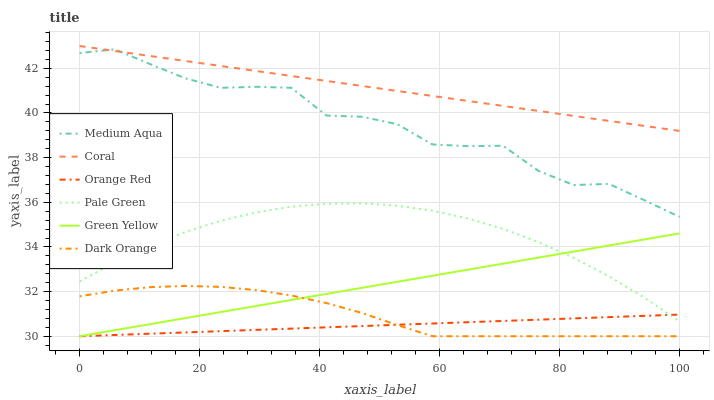Does Orange Red have the minimum area under the curve?
Answer yes or no. Yes. Does Coral have the maximum area under the curve?
Answer yes or no. Yes. Does Pale Green have the minimum area under the curve?
Answer yes or no. No. Does Pale Green have the maximum area under the curve?
Answer yes or no. No. Is Green Yellow the smoothest?
Answer yes or no. Yes. Is Medium Aqua the roughest?
Answer yes or no. Yes. Is Coral the smoothest?
Answer yes or no. No. Is Coral the roughest?
Answer yes or no. No. Does Dark Orange have the lowest value?
Answer yes or no. Yes. Does Pale Green have the lowest value?
Answer yes or no. No. Does Coral have the highest value?
Answer yes or no. Yes. Does Pale Green have the highest value?
Answer yes or no. No. Is Green Yellow less than Medium Aqua?
Answer yes or no. Yes. Is Coral greater than Orange Red?
Answer yes or no. Yes. Does Dark Orange intersect Orange Red?
Answer yes or no. Yes. Is Dark Orange less than Orange Red?
Answer yes or no. No. Is Dark Orange greater than Orange Red?
Answer yes or no. No. Does Green Yellow intersect Medium Aqua?
Answer yes or no. No. 